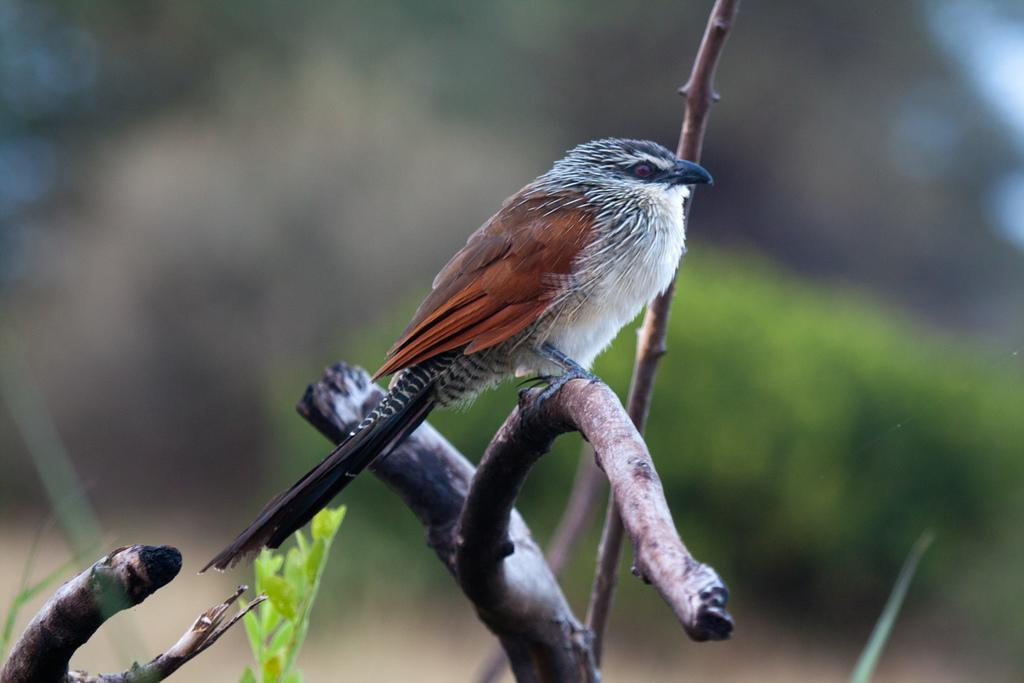What type of animal can be seen in the image? There is a bird in the image. Where is the bird located? The bird is on a branch. What else can be seen in the image besides the bird? There are leaves in the image. Can you describe the background of the image? The background of the image is blurry. What type of mailbox can be seen in the image? There is no mailbox present in the image. What system does the bird use to fulfill its desires in the image? The image does not depict any desires or systems related to the bird. 